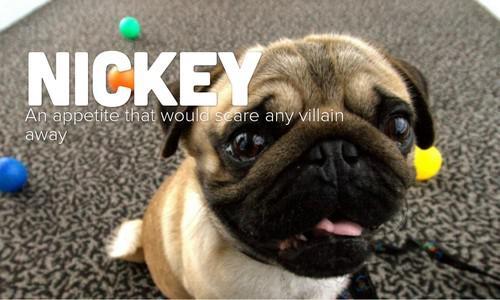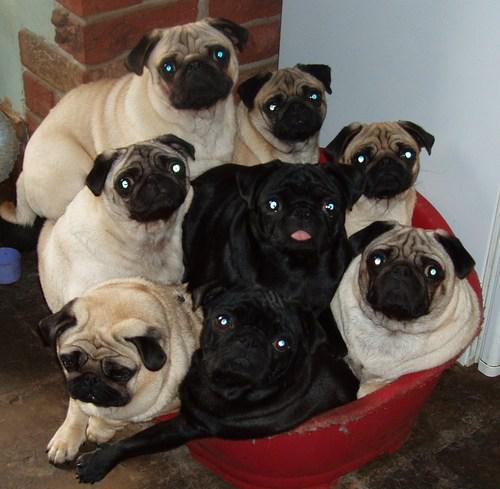The first image is the image on the left, the second image is the image on the right. Evaluate the accuracy of this statement regarding the images: "In one of the images, at least one of the dogs is entirely black.". Is it true? Answer yes or no. Yes. The first image is the image on the left, the second image is the image on the right. Evaluate the accuracy of this statement regarding the images: "An image contains at least three pug dogs dressed in garments other than dog collars.". Is it true? Answer yes or no. No. 